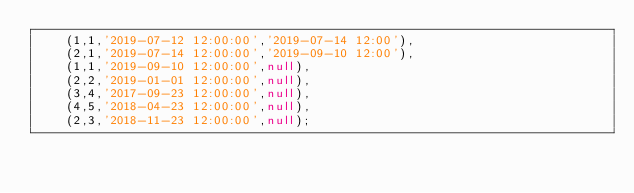Convert code to text. <code><loc_0><loc_0><loc_500><loc_500><_SQL_>    (1,1,'2019-07-12 12:00:00','2019-07-14 12:00'),
    (2,1,'2019-07-14 12:00:00','2019-09-10 12:00'),
    (1,1,'2019-09-10 12:00:00',null),
    (2,2,'2019-01-01 12:00:00',null),
    (3,4,'2017-09-23 12:00:00',null),
    (4,5,'2018-04-23 12:00:00',null),
    (2,3,'2018-11-23 12:00:00',null);</code> 